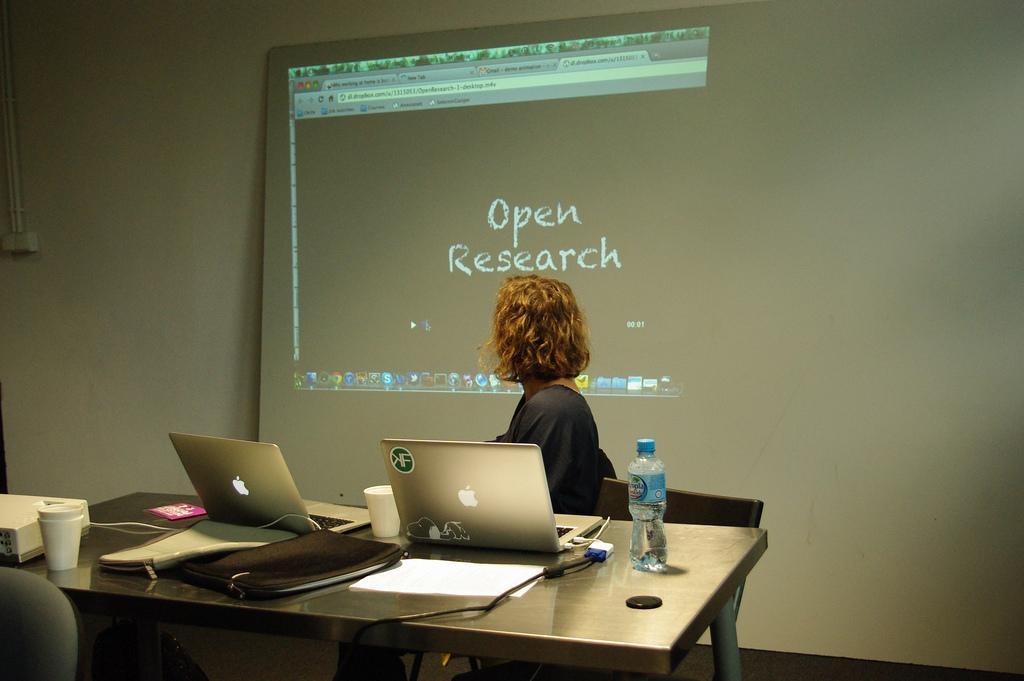In one or two sentences, can you explain what this image depicts? In the center of the image there is a woman sitting at the table. On the table we can see laptops, glass, water bottle, papers and bags. In the background there is a screen. 